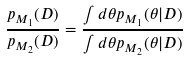Convert formula to latex. <formula><loc_0><loc_0><loc_500><loc_500>\frac { p _ { M _ { 1 } } ( D ) } { p _ { M _ { 2 } } ( D ) } = \frac { \int d \theta p _ { M _ { 1 } } ( \theta | D ) } { \int d \theta p _ { M _ { 2 } } ( \theta | D ) }</formula> 